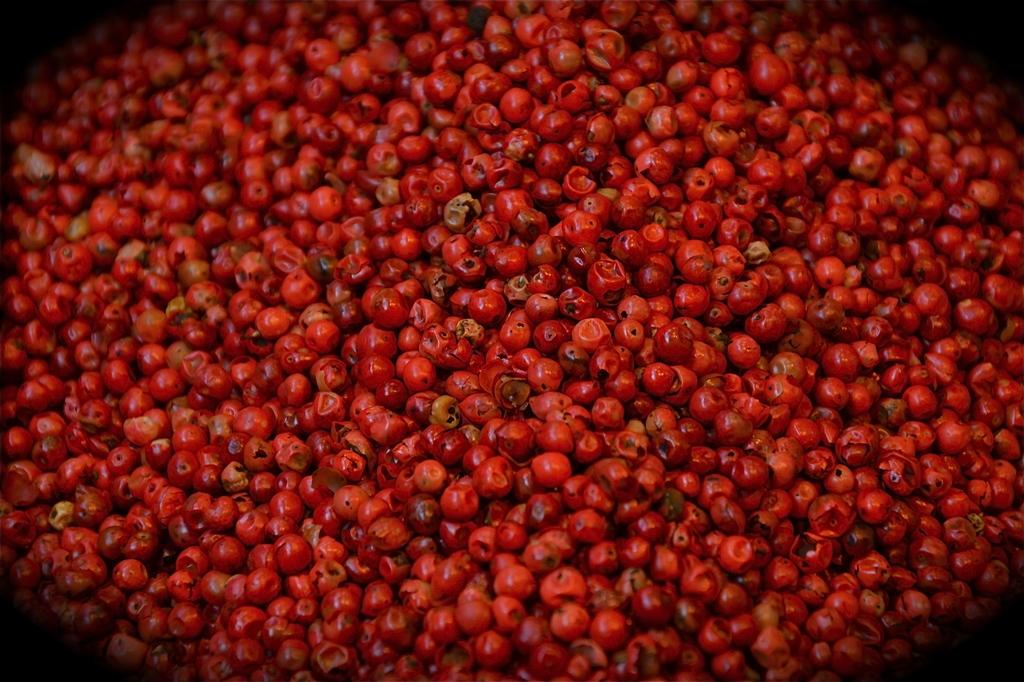What type of fruit is present in the image? There are berries in the image. What is the color of the berries? The berries are red in color. What type of pipe is visible in the image? There is no pipe present in the image; it only features berries. What is the berries being used for in the image? The image does not show the berries being used for any specific purpose. 